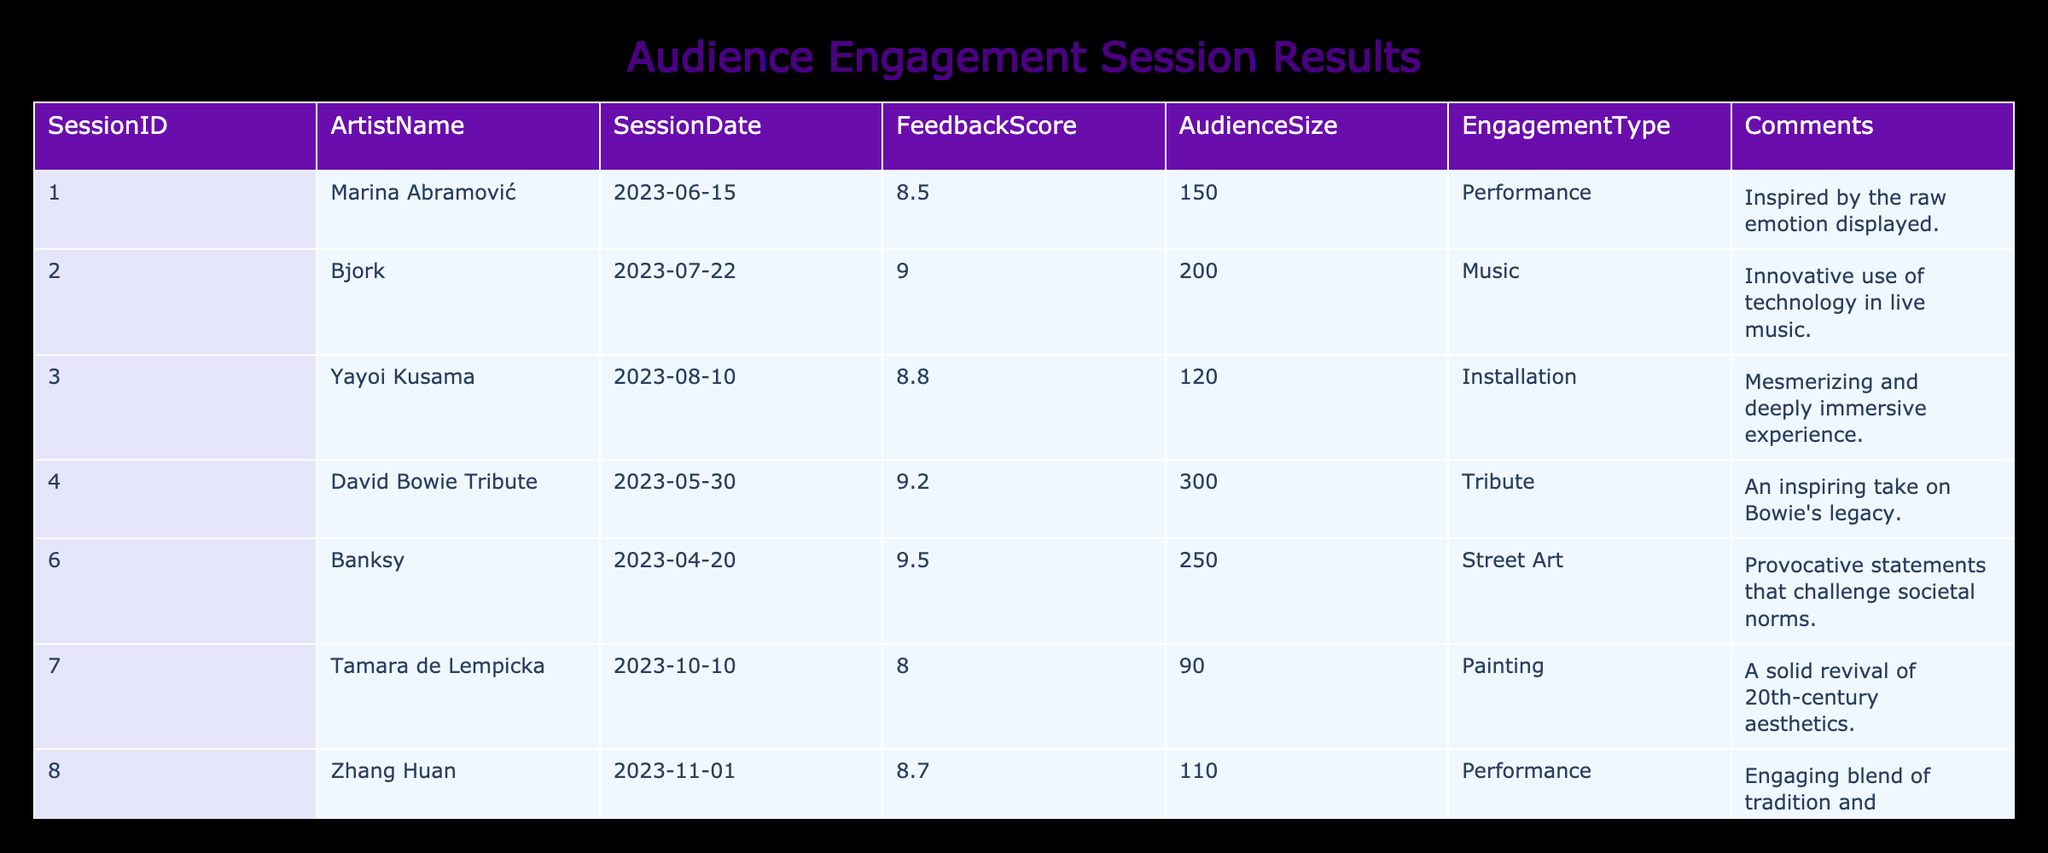What is the highest Feedback Score recorded in the table? The table lists various feedback scores from different sessions, and I will look at the FeedbackScore column to find the maximum value. The maximum score is 9.5, which corresponds to Banksy's session.
Answer: 9.5 Which artist had the lowest Feedback Score? By examining the FeedbackScore column, I can find the lowest score among the listed sessions. The lowest score is 8.0, attributed to Tamara de Lempicka's session.
Answer: 8.0 How many sessions received a Feedback Score of 9 or above? I will count the number of sessions with scores of 9.0 or higher by filtering the FeedbackScore column. The sessions scoring 9 or above are those by Bjork, David Bowie Tribute, and Banksy, totaling three sessions.
Answer: 3 What is the average Feedback Score of all sessions? I sum the Feedback Scores and divide by the number of sessions to find the average. The total score is (8.5 + 9.0 + 8.8 + 9.2 + 9.5 + 8.0 + 8.7) = 61.7. There are 7 sessions, so the average is 61.7/7 = approximately 8.81.
Answer: 8.81 Is there any session that had both the highest score and the largest audience size? I need to check the values in the FeedbackScore and AudienceSize columns for all sessions. The highest score is 9.5, from Banksy, which had an audience size of 250. No other session has a higher score with a larger audience size, making this statement true.
Answer: Yes 